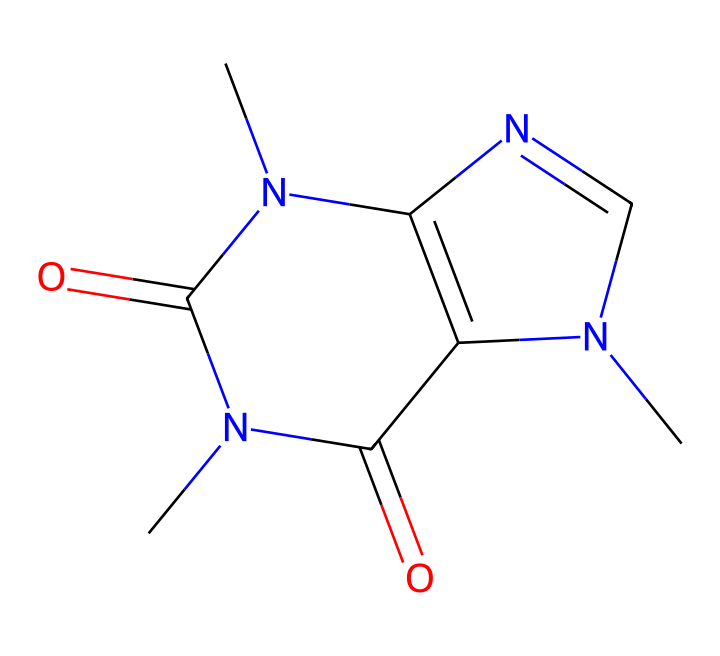What is the molecular formula of caffeine? Analyzing the SMILES representation, we can identify the counts of each type of atom present in the structure. There are 8 carbon (C) atoms, 10 hydrogen (H) atoms, 4 nitrogen (N) atoms, and 2 oxygen (O) atoms. Therefore, the molecular formula is C8H10N4O2.
Answer: C8H10N4O2 How many rings are present in the caffeine structure? By examining the structure from the SMILES representation, we can observe the cyclic nature with the presence of two fused rings. Specifically, there are two rings formed from the connection of nitrogen and carbon atoms.
Answer: 2 Which atoms in caffeine are responsible for its basic properties? The presence of nitrogen atoms in the structure contributes to the basic properties of caffeine. These nitrogen atoms are part of the aromatic rings that exhibit basic characteristics, influencing the caffeine's solubility and reactivity.
Answer: nitrogen What is the primary functional group present in caffeine? Caffeine's structure contains amide groups, which are characterized by the carbonyl (C=O) bonded to a nitrogen (N). This structural motif is crucial for the activity of caffeine as a stimulant.
Answer: amide Is caffeine an acid or a base? The nitrogen atoms, specifically their lone pairs, can accept protons, indicating that caffeine functions as a weak base. The structure and overall behavior of caffeine support this.
Answer: base 